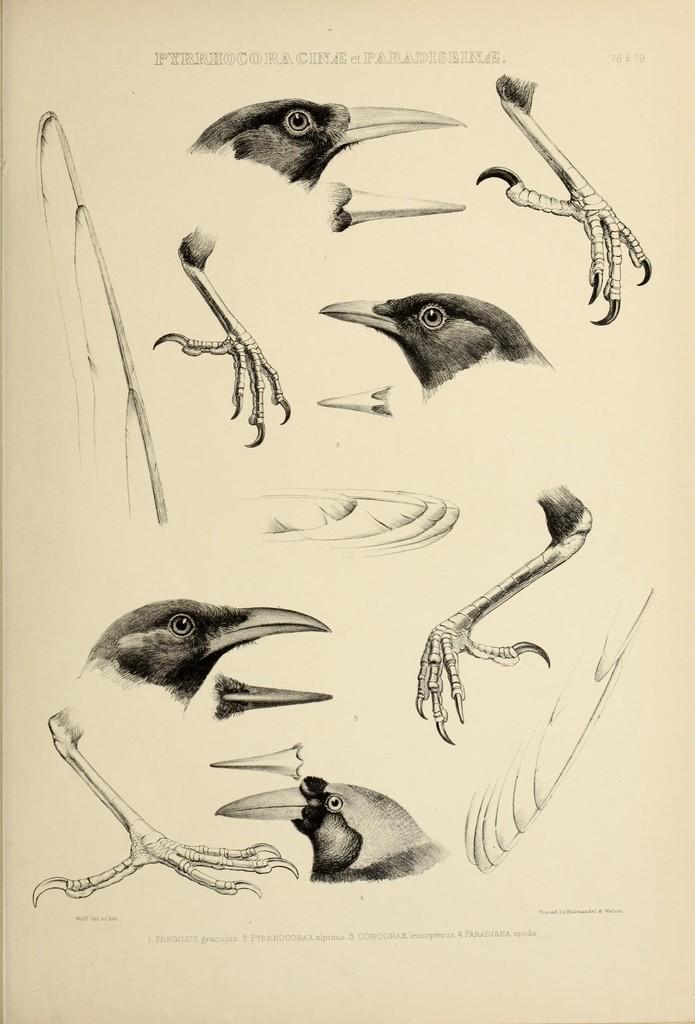Can you describe this image briefly? In this picture i can see there are some birds and their feathers and claws and this is a drawing. 